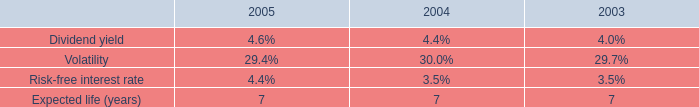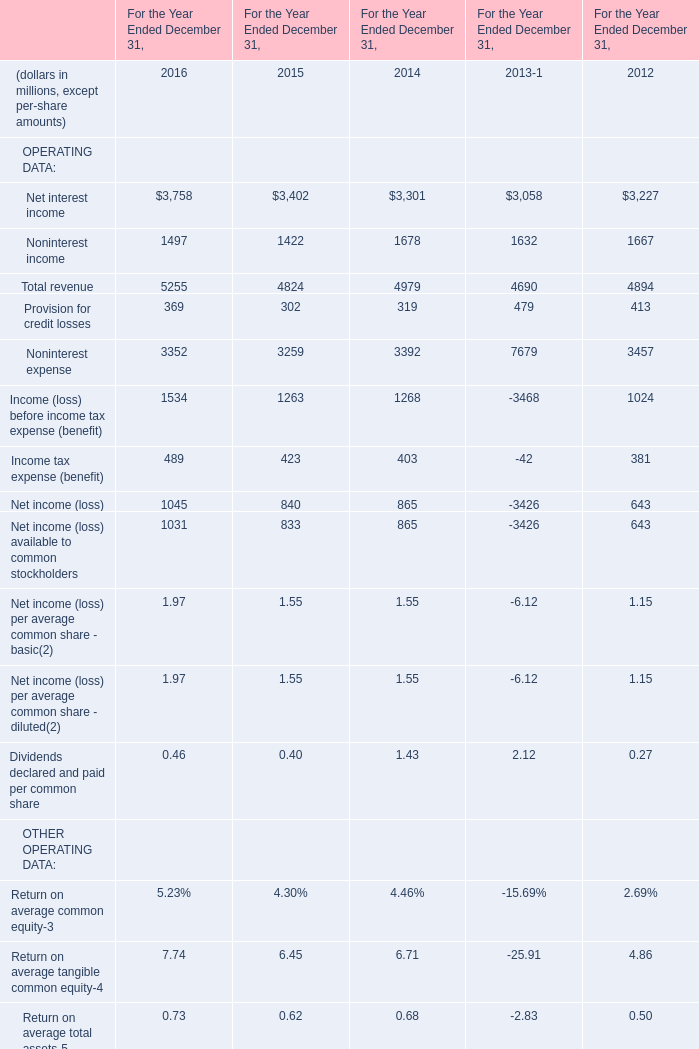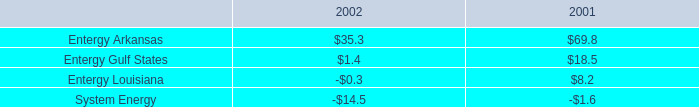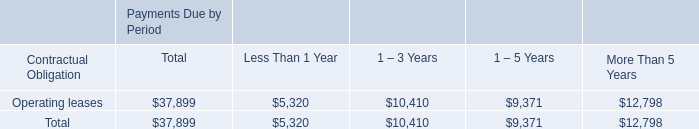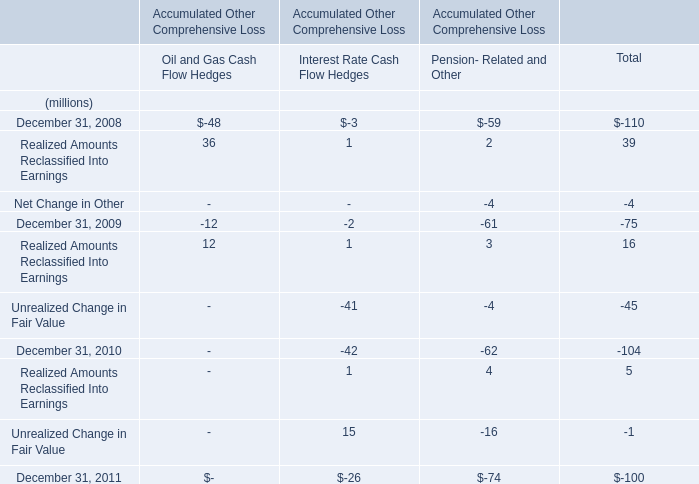In the year with largest amount of total revenue what's the increasing rate of net interest income? 
Computations: ((3758 - 3402) / 3402)
Answer: 0.10464. 